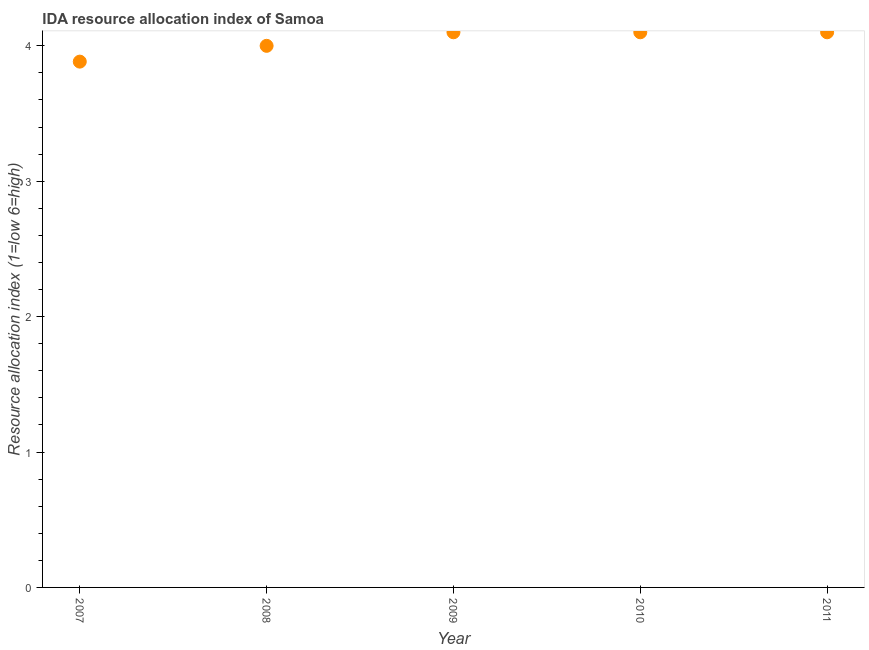What is the ida resource allocation index in 2007?
Make the answer very short. 3.88. Across all years, what is the maximum ida resource allocation index?
Ensure brevity in your answer.  4.1. Across all years, what is the minimum ida resource allocation index?
Your response must be concise. 3.88. In which year was the ida resource allocation index maximum?
Provide a succinct answer. 2009. What is the sum of the ida resource allocation index?
Your answer should be very brief. 20.18. What is the average ida resource allocation index per year?
Make the answer very short. 4.04. What is the median ida resource allocation index?
Provide a succinct answer. 4.1. What is the ratio of the ida resource allocation index in 2009 to that in 2010?
Your response must be concise. 1. Is the ida resource allocation index in 2007 less than that in 2011?
Your response must be concise. Yes. Is the difference between the ida resource allocation index in 2007 and 2008 greater than the difference between any two years?
Your answer should be compact. No. Is the sum of the ida resource allocation index in 2008 and 2010 greater than the maximum ida resource allocation index across all years?
Your response must be concise. Yes. What is the difference between the highest and the lowest ida resource allocation index?
Ensure brevity in your answer.  0.22. How many dotlines are there?
Provide a short and direct response. 1. How many years are there in the graph?
Give a very brief answer. 5. What is the difference between two consecutive major ticks on the Y-axis?
Provide a succinct answer. 1. Does the graph contain any zero values?
Ensure brevity in your answer.  No. What is the title of the graph?
Offer a very short reply. IDA resource allocation index of Samoa. What is the label or title of the X-axis?
Make the answer very short. Year. What is the label or title of the Y-axis?
Your response must be concise. Resource allocation index (1=low 6=high). What is the Resource allocation index (1=low 6=high) in 2007?
Offer a very short reply. 3.88. What is the Resource allocation index (1=low 6=high) in 2009?
Ensure brevity in your answer.  4.1. What is the difference between the Resource allocation index (1=low 6=high) in 2007 and 2008?
Your response must be concise. -0.12. What is the difference between the Resource allocation index (1=low 6=high) in 2007 and 2009?
Provide a succinct answer. -0.22. What is the difference between the Resource allocation index (1=low 6=high) in 2007 and 2010?
Offer a terse response. -0.22. What is the difference between the Resource allocation index (1=low 6=high) in 2007 and 2011?
Your answer should be very brief. -0.22. What is the difference between the Resource allocation index (1=low 6=high) in 2008 and 2009?
Your response must be concise. -0.1. What is the difference between the Resource allocation index (1=low 6=high) in 2008 and 2010?
Offer a terse response. -0.1. What is the difference between the Resource allocation index (1=low 6=high) in 2009 and 2011?
Keep it short and to the point. 0. What is the difference between the Resource allocation index (1=low 6=high) in 2010 and 2011?
Provide a succinct answer. 0. What is the ratio of the Resource allocation index (1=low 6=high) in 2007 to that in 2008?
Offer a terse response. 0.97. What is the ratio of the Resource allocation index (1=low 6=high) in 2007 to that in 2009?
Provide a short and direct response. 0.95. What is the ratio of the Resource allocation index (1=low 6=high) in 2007 to that in 2010?
Offer a terse response. 0.95. What is the ratio of the Resource allocation index (1=low 6=high) in 2007 to that in 2011?
Provide a short and direct response. 0.95. What is the ratio of the Resource allocation index (1=low 6=high) in 2008 to that in 2011?
Offer a terse response. 0.98. What is the ratio of the Resource allocation index (1=low 6=high) in 2010 to that in 2011?
Your answer should be compact. 1. 